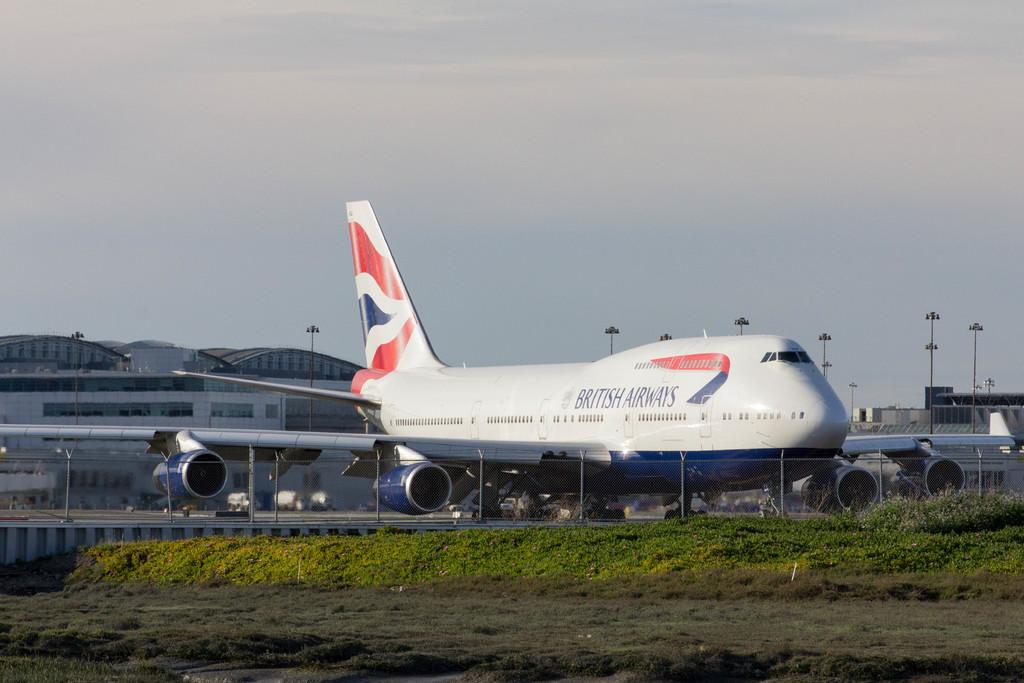<image>
Offer a succinct explanation of the picture presented. A big Birtish Airways jet on the runway. 